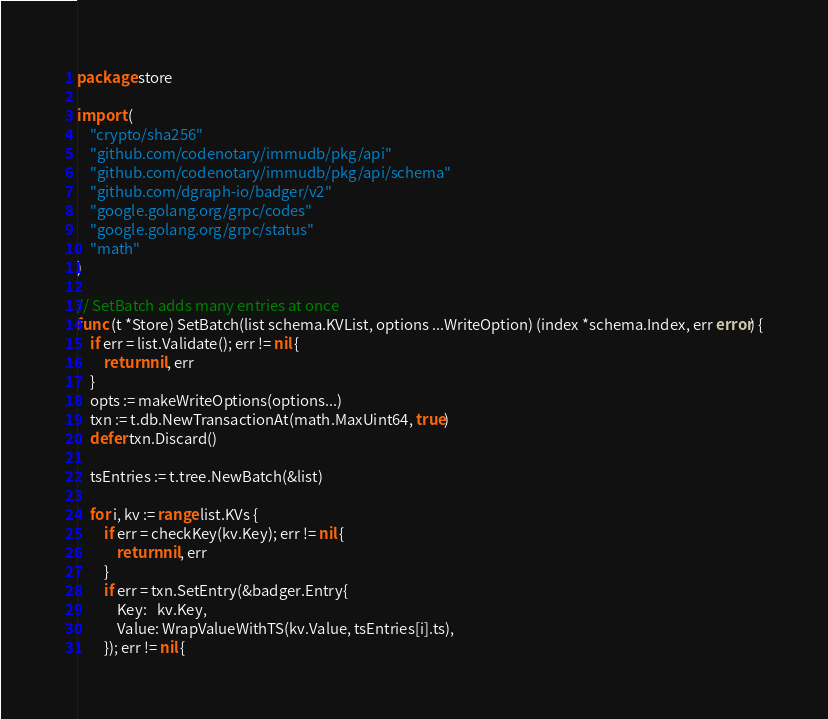<code> <loc_0><loc_0><loc_500><loc_500><_Go_>package store

import (
	"crypto/sha256"
	"github.com/codenotary/immudb/pkg/api"
	"github.com/codenotary/immudb/pkg/api/schema"
	"github.com/dgraph-io/badger/v2"
	"google.golang.org/grpc/codes"
	"google.golang.org/grpc/status"
	"math"
)

// SetBatch adds many entries at once
func (t *Store) SetBatch(list schema.KVList, options ...WriteOption) (index *schema.Index, err error) {
	if err = list.Validate(); err != nil {
		return nil, err
	}
	opts := makeWriteOptions(options...)
	txn := t.db.NewTransactionAt(math.MaxUint64, true)
	defer txn.Discard()

	tsEntries := t.tree.NewBatch(&list)

	for i, kv := range list.KVs {
		if err = checkKey(kv.Key); err != nil {
			return nil, err
		}
		if err = txn.SetEntry(&badger.Entry{
			Key:   kv.Key,
			Value: WrapValueWithTS(kv.Value, tsEntries[i].ts),
		}); err != nil {</code> 